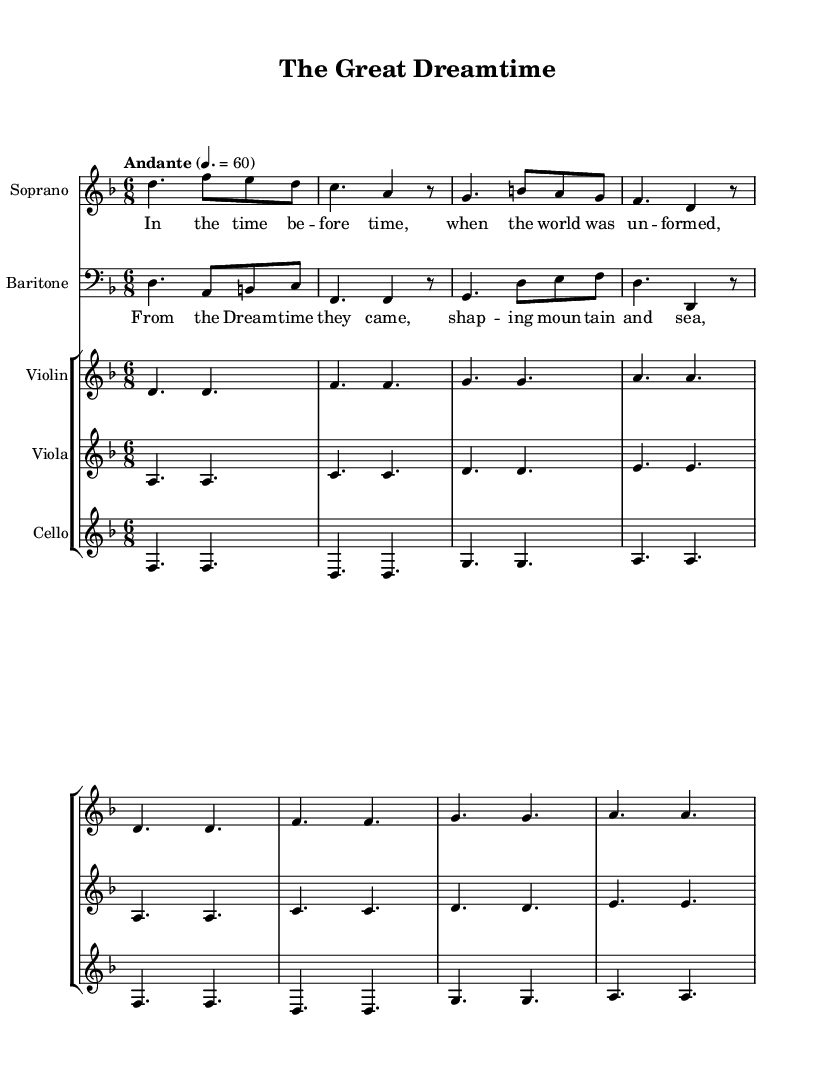What is the key signature of this music? The key signature is indicated by the key signature marking at the beginning of the staff. Here, it shows one flat, which means the key is D minor.
Answer: D minor What is the time signature of this music? The time signature is represented by two numbers at the beginning of the score. Here, it shows 6 over 8, meaning there are six beats in each measure, and an eighth note gets one beat.
Answer: 6/8 What is the tempo marking for this piece? The tempo marking is found at the start following the key and time signature. It specifies "Andante" with a metronome marking of 4 equals 60, indicating a moderate pace.
Answer: Andante 4. = 60 How many instruments are featured in this composition? By counting the ensembles listed at the beginning, we can see there are four distinct parts specified: Soprano, Baritone, Violin, Viola, and Cello. Therefore, the total count includes four instrumental parts plus the two vocal parts.
Answer: Six Which section contains the lyrics "From the Dreamtime they came"? The specific lyrics can be found as a part of the chorus, indicated below the baritone staff by the lyrics stanza that starts with "From the Dreamtime."
Answer: Chorus What type of ensemble is this piece written for? By examining the instrument instrumentation, we notice that it includes vocal parts (Soprano and Baritone) along with string instruments—Violin, Viola, and Cello. Hence, it is a mixed vocal and string ensemble.
Answer: Mixed vocal and string ensemble 